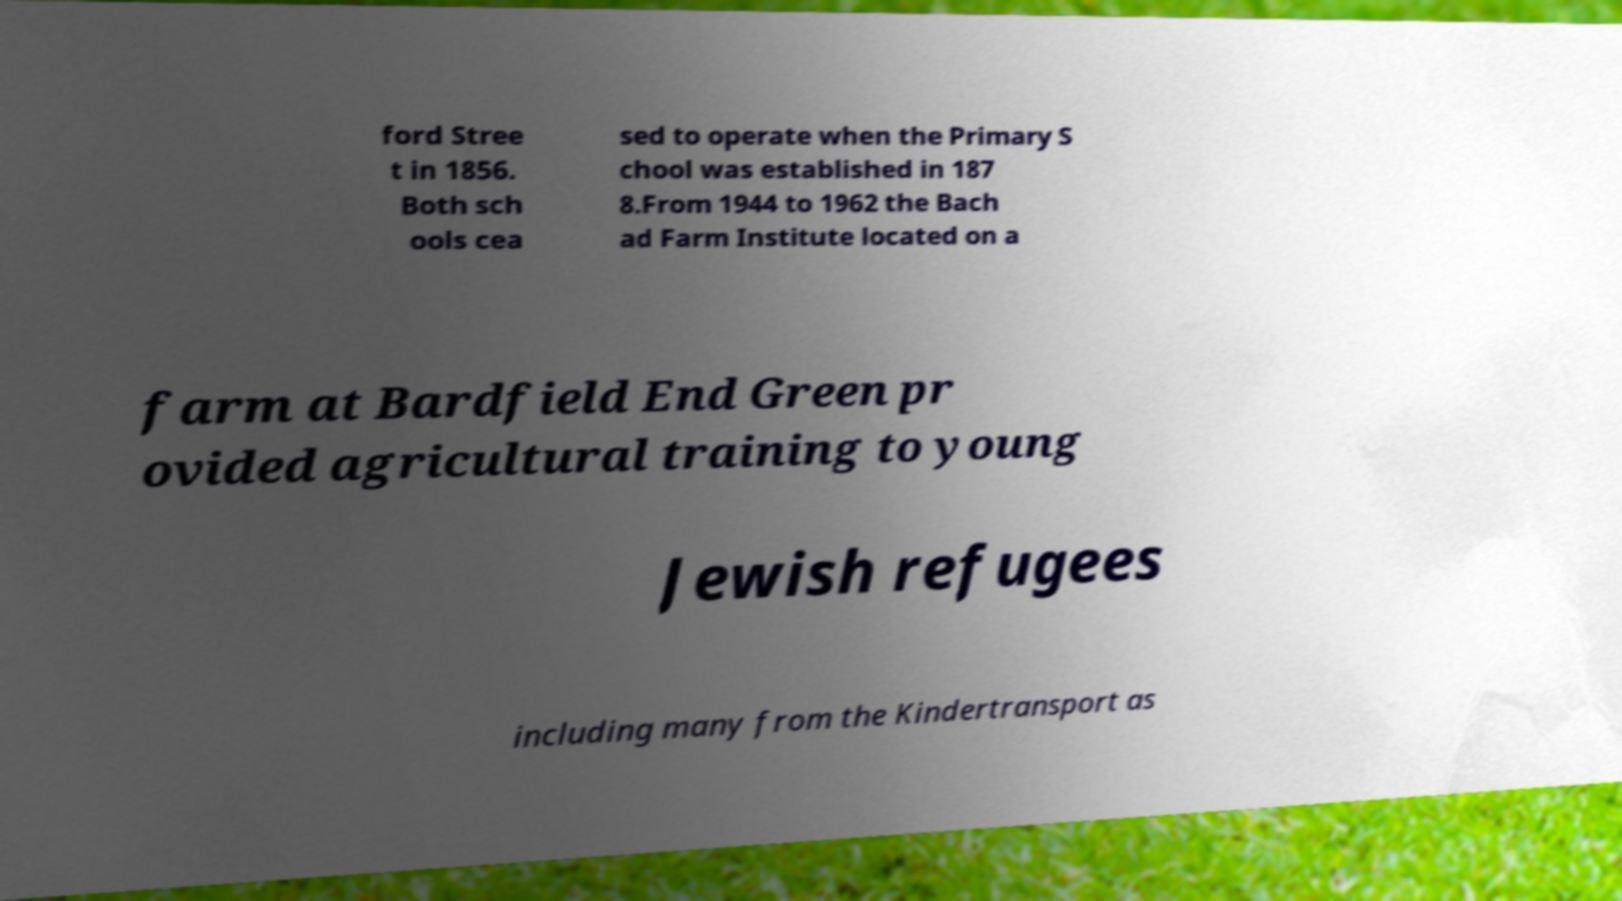Could you extract and type out the text from this image? ford Stree t in 1856. Both sch ools cea sed to operate when the Primary S chool was established in 187 8.From 1944 to 1962 the Bach ad Farm Institute located on a farm at Bardfield End Green pr ovided agricultural training to young Jewish refugees including many from the Kindertransport as 